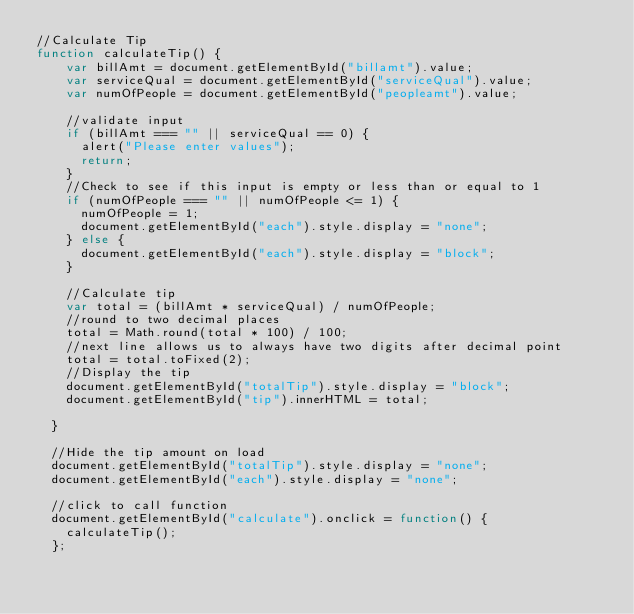<code> <loc_0><loc_0><loc_500><loc_500><_JavaScript_>//Calculate Tip
function calculateTip() {
    var billAmt = document.getElementById("billamt").value;
    var serviceQual = document.getElementById("serviceQual").value;
    var numOfPeople = document.getElementById("peopleamt").value;
  
    //validate input
    if (billAmt === "" || serviceQual == 0) {
      alert("Please enter values");
      return;
    }
    //Check to see if this input is empty or less than or equal to 1
    if (numOfPeople === "" || numOfPeople <= 1) {
      numOfPeople = 1;
      document.getElementById("each").style.display = "none";
    } else {
      document.getElementById("each").style.display = "block";
    }
  
    //Calculate tip
    var total = (billAmt * serviceQual) / numOfPeople;
    //round to two decimal places
    total = Math.round(total * 100) / 100;
    //next line allows us to always have two digits after decimal point
    total = total.toFixed(2);
    //Display the tip
    document.getElementById("totalTip").style.display = "block";
    document.getElementById("tip").innerHTML = total;
  
  }
  
  //Hide the tip amount on load
  document.getElementById("totalTip").style.display = "none";
  document.getElementById("each").style.display = "none";
  
  //click to call function
  document.getElementById("calculate").onclick = function() {
    calculateTip();
  };</code> 